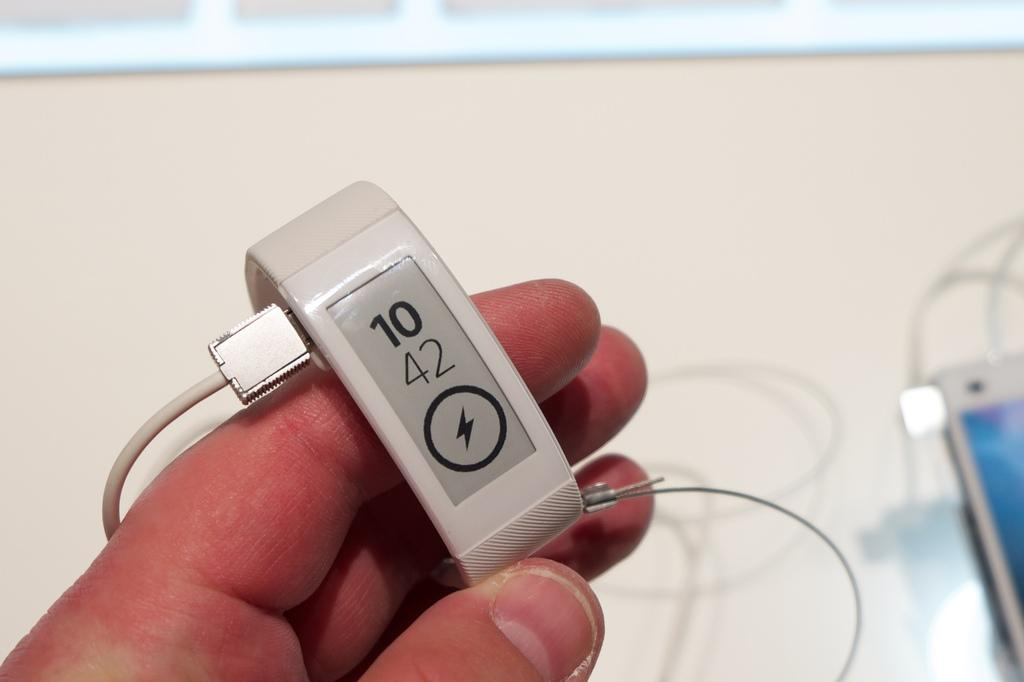<image>
Provide a brief description of the given image. A gray slim smartwatch sowing the time of 10:42 being charged. 